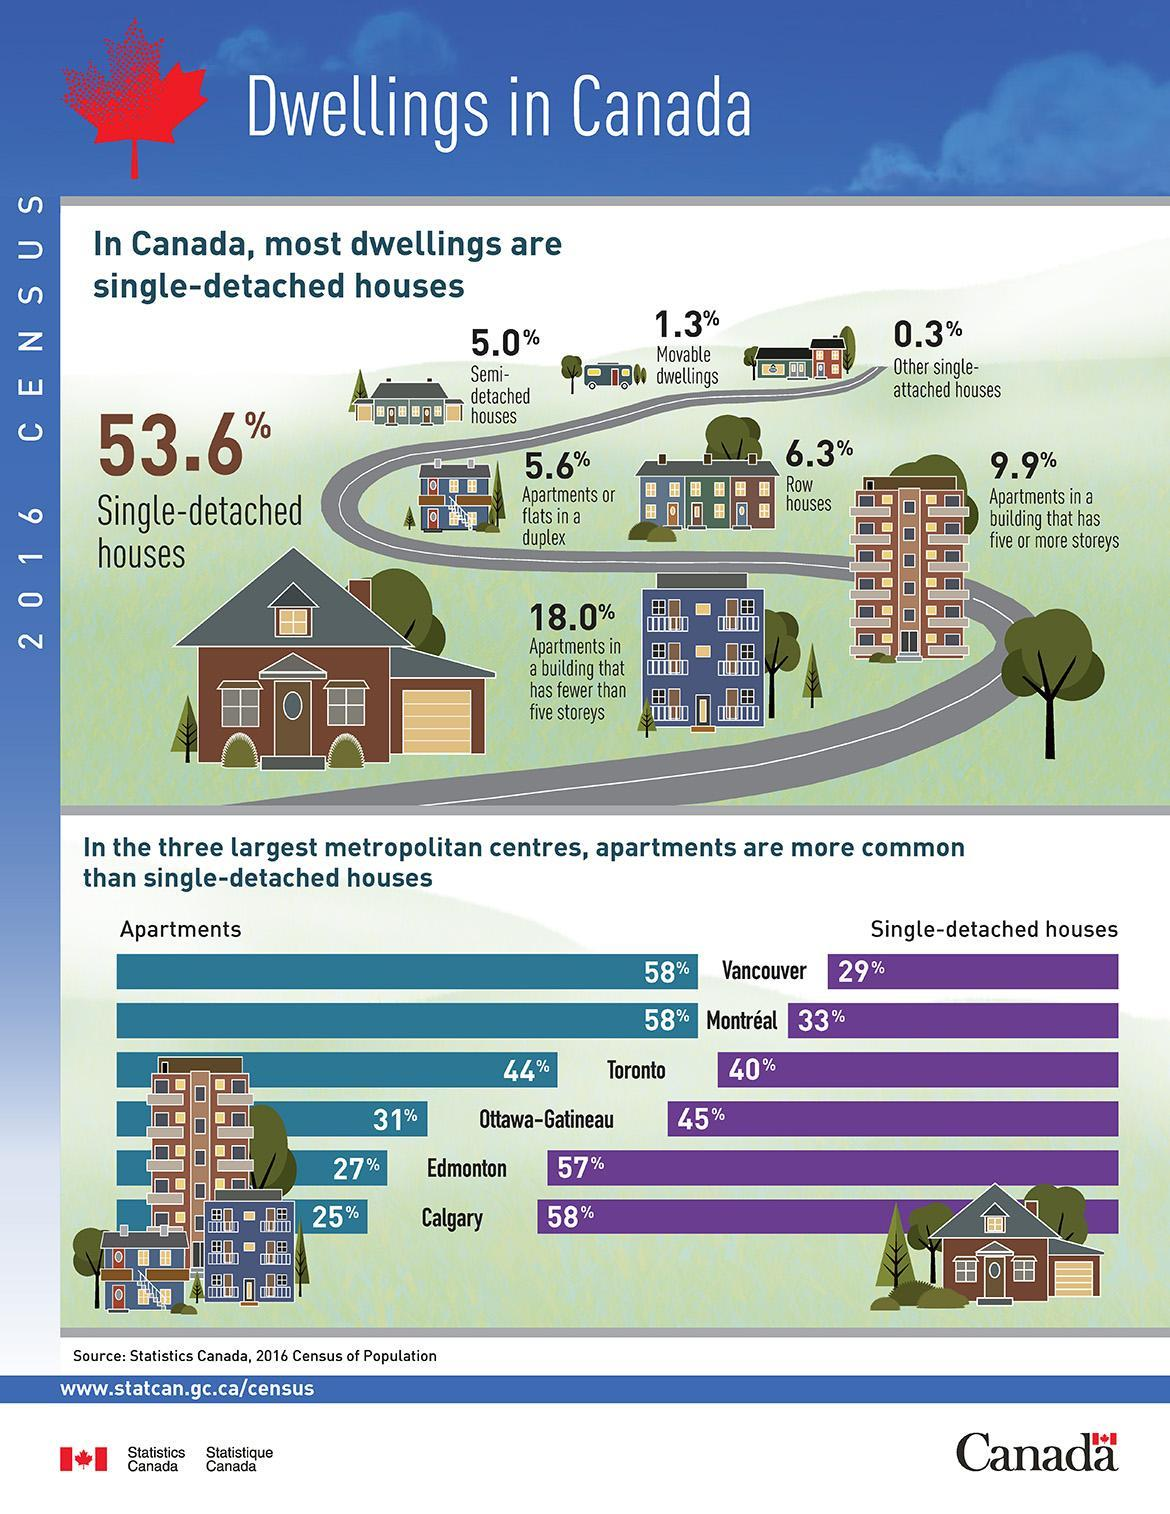What is the percentage of apartments and Single-detached houses in Vancouver, taken together?
Answer the question with a short phrase. 87% What is the percentage of row houses and movable dwellings, taken together? 7.6% What is the percentage of apartments and Single-detached houses in Calgary, taken together? 83% What is the percentage of other single-attached houses? 0.3% What is the percentage of apartments or flats in a duplex? 5.6% What is the percentage of apartments and Single-detached houses in Toronto, taken together? 84% What is the percentage of row houses? 6.3% What is the percentage of apartments in Toronto and Edmonton, taken together? 71% What is the percentage of Semi-detached houses? 5.0% What is the percentage of moveable dwellings? 1.3% 